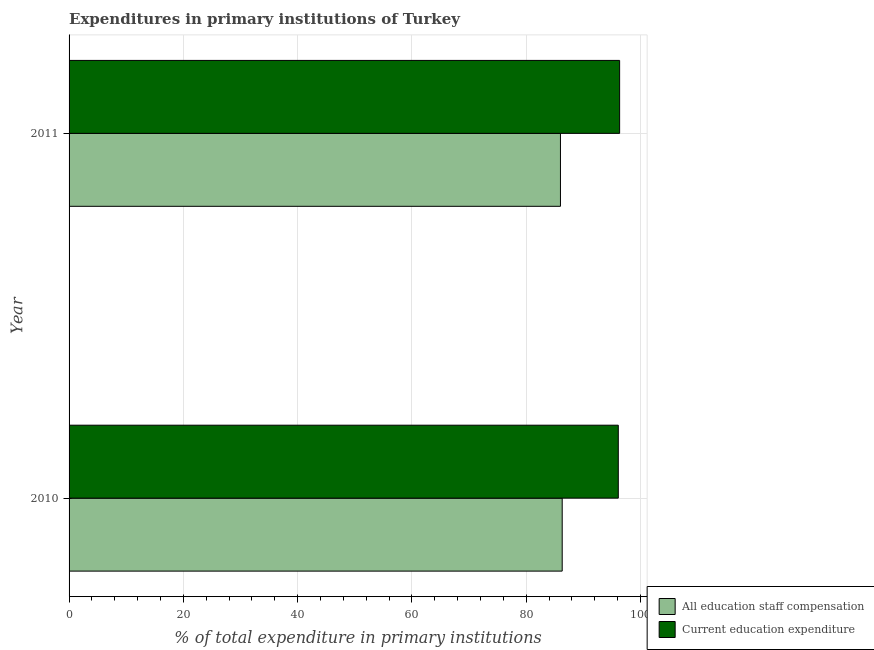How many different coloured bars are there?
Offer a very short reply. 2. How many groups of bars are there?
Ensure brevity in your answer.  2. Are the number of bars on each tick of the Y-axis equal?
Give a very brief answer. Yes. How many bars are there on the 1st tick from the top?
Your response must be concise. 2. How many bars are there on the 1st tick from the bottom?
Keep it short and to the point. 2. What is the label of the 1st group of bars from the top?
Offer a very short reply. 2011. In how many cases, is the number of bars for a given year not equal to the number of legend labels?
Offer a very short reply. 0. What is the expenditure in education in 2010?
Your response must be concise. 96.11. Across all years, what is the maximum expenditure in staff compensation?
Make the answer very short. 86.29. Across all years, what is the minimum expenditure in staff compensation?
Offer a very short reply. 85.99. In which year was the expenditure in staff compensation maximum?
Offer a very short reply. 2010. In which year was the expenditure in education minimum?
Ensure brevity in your answer.  2010. What is the total expenditure in staff compensation in the graph?
Offer a terse response. 172.28. What is the difference between the expenditure in education in 2010 and that in 2011?
Provide a succinct answer. -0.23. What is the difference between the expenditure in staff compensation in 2011 and the expenditure in education in 2010?
Ensure brevity in your answer.  -10.12. What is the average expenditure in staff compensation per year?
Offer a very short reply. 86.14. In the year 2010, what is the difference between the expenditure in staff compensation and expenditure in education?
Offer a terse response. -9.82. Is the expenditure in education in 2010 less than that in 2011?
Provide a short and direct response. Yes. Is the difference between the expenditure in staff compensation in 2010 and 2011 greater than the difference between the expenditure in education in 2010 and 2011?
Your answer should be very brief. Yes. What does the 2nd bar from the top in 2011 represents?
Offer a terse response. All education staff compensation. What does the 1st bar from the bottom in 2011 represents?
Your response must be concise. All education staff compensation. How many years are there in the graph?
Ensure brevity in your answer.  2. What is the difference between two consecutive major ticks on the X-axis?
Ensure brevity in your answer.  20. Does the graph contain any zero values?
Offer a very short reply. No. Does the graph contain grids?
Your answer should be very brief. Yes. How many legend labels are there?
Give a very brief answer. 2. How are the legend labels stacked?
Make the answer very short. Vertical. What is the title of the graph?
Make the answer very short. Expenditures in primary institutions of Turkey. Does "Number of arrivals" appear as one of the legend labels in the graph?
Make the answer very short. No. What is the label or title of the X-axis?
Provide a succinct answer. % of total expenditure in primary institutions. What is the label or title of the Y-axis?
Keep it short and to the point. Year. What is the % of total expenditure in primary institutions of All education staff compensation in 2010?
Provide a succinct answer. 86.29. What is the % of total expenditure in primary institutions in Current education expenditure in 2010?
Offer a very short reply. 96.11. What is the % of total expenditure in primary institutions of All education staff compensation in 2011?
Offer a terse response. 85.99. What is the % of total expenditure in primary institutions of Current education expenditure in 2011?
Keep it short and to the point. 96.34. Across all years, what is the maximum % of total expenditure in primary institutions in All education staff compensation?
Make the answer very short. 86.29. Across all years, what is the maximum % of total expenditure in primary institutions in Current education expenditure?
Offer a very short reply. 96.34. Across all years, what is the minimum % of total expenditure in primary institutions of All education staff compensation?
Provide a succinct answer. 85.99. Across all years, what is the minimum % of total expenditure in primary institutions of Current education expenditure?
Provide a short and direct response. 96.11. What is the total % of total expenditure in primary institutions in All education staff compensation in the graph?
Offer a terse response. 172.28. What is the total % of total expenditure in primary institutions in Current education expenditure in the graph?
Your response must be concise. 192.44. What is the difference between the % of total expenditure in primary institutions of All education staff compensation in 2010 and that in 2011?
Offer a terse response. 0.31. What is the difference between the % of total expenditure in primary institutions of Current education expenditure in 2010 and that in 2011?
Give a very brief answer. -0.23. What is the difference between the % of total expenditure in primary institutions in All education staff compensation in 2010 and the % of total expenditure in primary institutions in Current education expenditure in 2011?
Keep it short and to the point. -10.05. What is the average % of total expenditure in primary institutions in All education staff compensation per year?
Your response must be concise. 86.14. What is the average % of total expenditure in primary institutions in Current education expenditure per year?
Your answer should be very brief. 96.22. In the year 2010, what is the difference between the % of total expenditure in primary institutions of All education staff compensation and % of total expenditure in primary institutions of Current education expenditure?
Your response must be concise. -9.82. In the year 2011, what is the difference between the % of total expenditure in primary institutions of All education staff compensation and % of total expenditure in primary institutions of Current education expenditure?
Keep it short and to the point. -10.35. What is the difference between the highest and the second highest % of total expenditure in primary institutions in All education staff compensation?
Provide a short and direct response. 0.31. What is the difference between the highest and the second highest % of total expenditure in primary institutions of Current education expenditure?
Offer a terse response. 0.23. What is the difference between the highest and the lowest % of total expenditure in primary institutions of All education staff compensation?
Your answer should be very brief. 0.31. What is the difference between the highest and the lowest % of total expenditure in primary institutions of Current education expenditure?
Your answer should be compact. 0.23. 